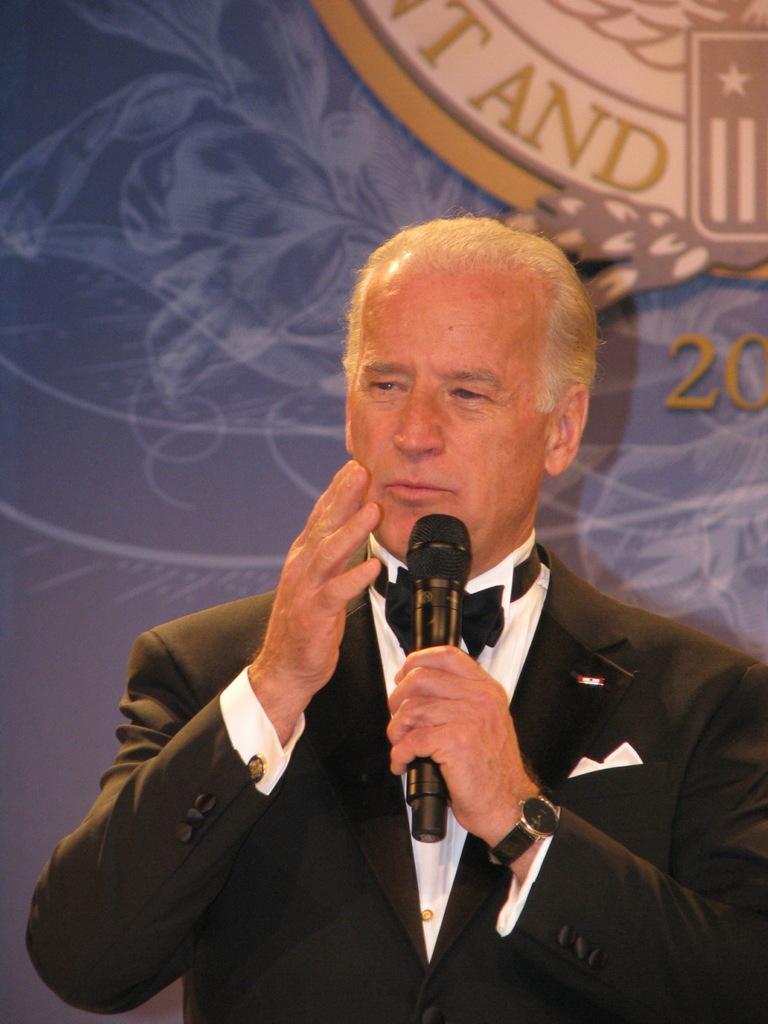Can you describe this image briefly? In this picture we can see man wore blazer, watch, ribbon to the shirt and holding mic in his hand and talking and in background we can see wall with logo. 